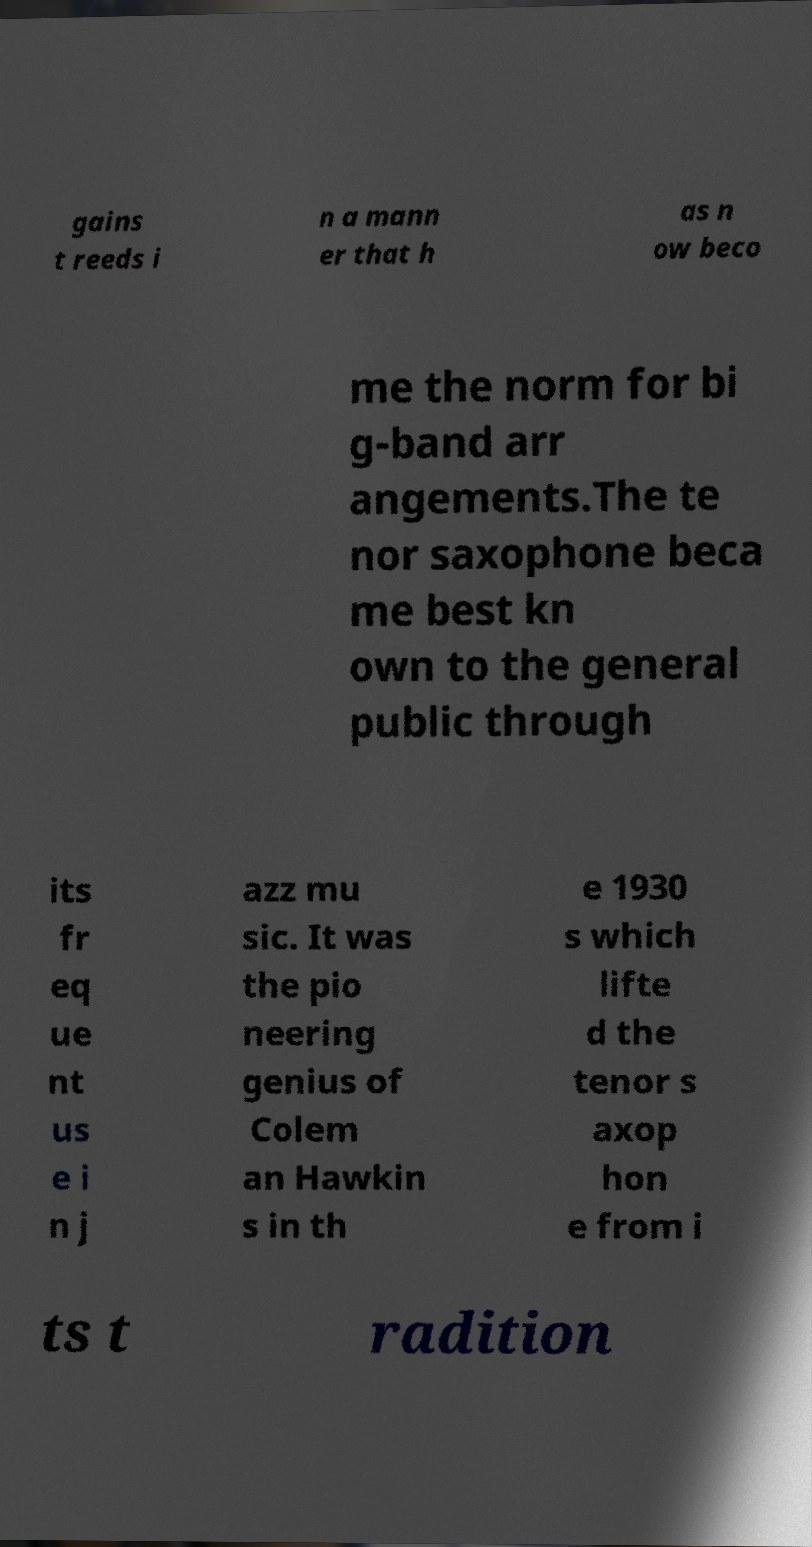For documentation purposes, I need the text within this image transcribed. Could you provide that? gains t reeds i n a mann er that h as n ow beco me the norm for bi g-band arr angements.The te nor saxophone beca me best kn own to the general public through its fr eq ue nt us e i n j azz mu sic. It was the pio neering genius of Colem an Hawkin s in th e 1930 s which lifte d the tenor s axop hon e from i ts t radition 